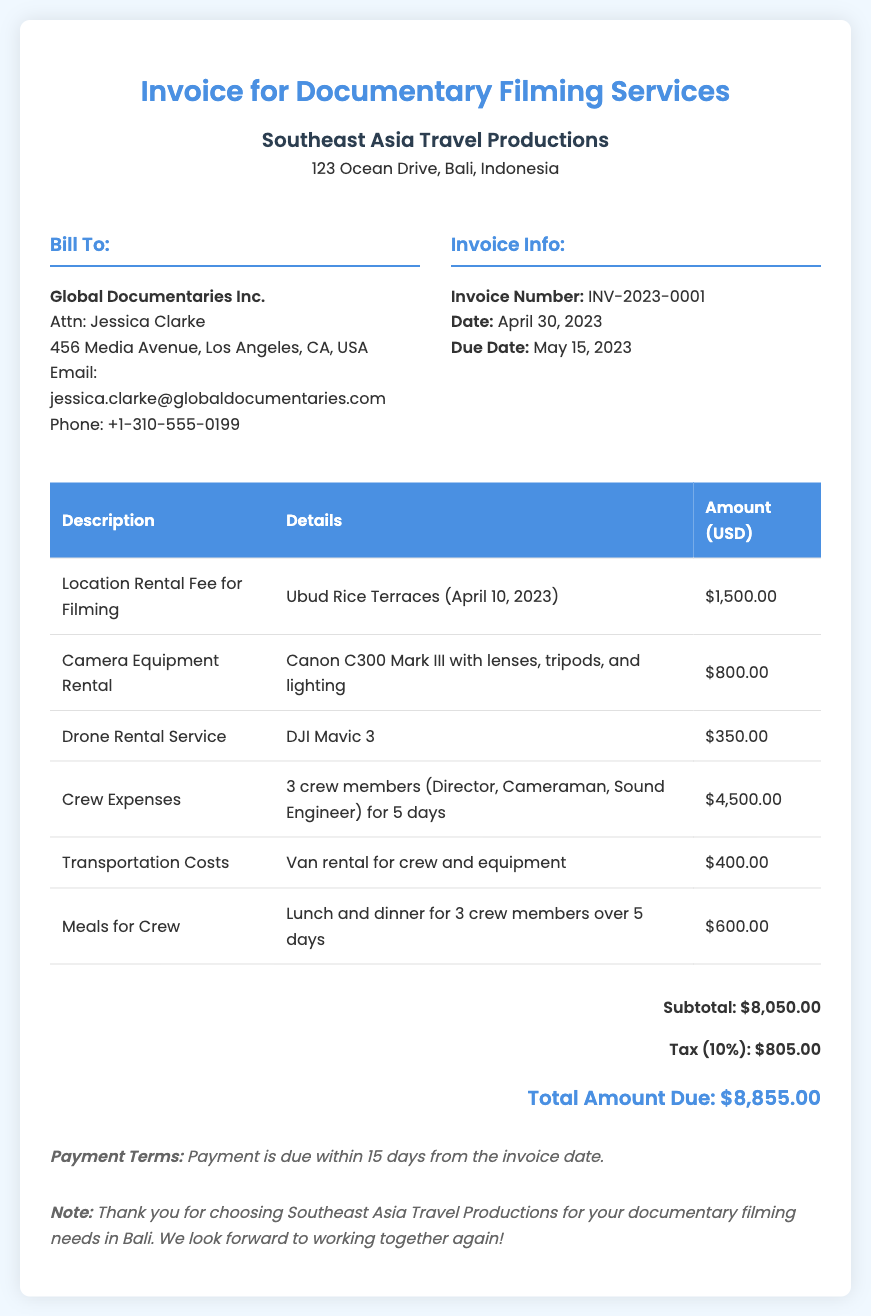what is the invoice number? The invoice number is mentioned in the invoice info section as INV-2023-0001.
Answer: INV-2023-0001 who is the client? The client's name is listed in the bill to section as Global Documentaries Inc.
Answer: Global Documentaries Inc what is the total amount due? The total amount due is calculated as the subtotal plus tax in the total section, which is $8,050.00 + $805.00.
Answer: $8,855.00 how many crew members are included in the crew expenses? The crew expenses row indicates there are 3 crew members.
Answer: 3 when was the filming location rented? The filming location rental date is specified as April 10, 2023.
Answer: April 10, 2023 what percentage is the tax applied? The tax rate applied is stated as 10% in the total section of the document.
Answer: 10% what services are included under camera equipment rental? The details provide that the camera equipment rental includes the Canon C300 Mark III with lenses, tripods, and lighting.
Answer: Canon C300 Mark III with lenses, tripods, and lighting what are the payment terms? The payment terms are specified in the document stating payment is due within 15 days from the invoice date.
Answer: Payment is due within 15 days from the invoice date 